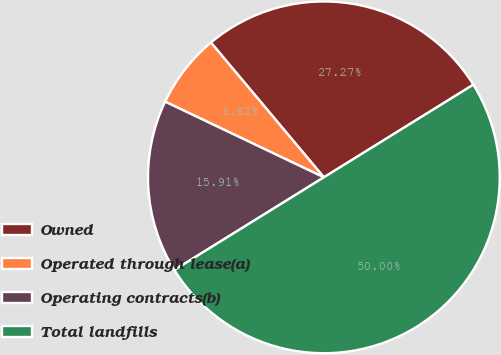<chart> <loc_0><loc_0><loc_500><loc_500><pie_chart><fcel>Owned<fcel>Operated through lease(a)<fcel>Operating contracts(b)<fcel>Total landfills<nl><fcel>27.27%<fcel>6.82%<fcel>15.91%<fcel>50.0%<nl></chart> 